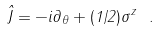<formula> <loc_0><loc_0><loc_500><loc_500>\hat { J } = - i \partial _ { \theta } + ( 1 / 2 ) \sigma ^ { z } \ .</formula> 